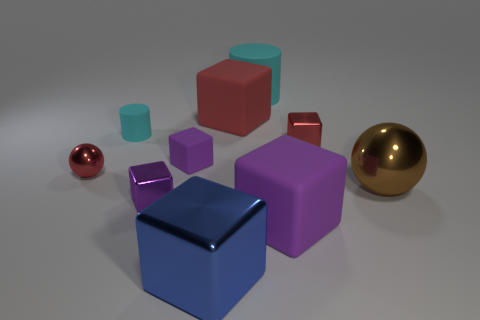There is a rubber object that is the same color as the small sphere; what is its size?
Keep it short and to the point. Large. Is the brown ball the same size as the purple shiny object?
Make the answer very short. No. The cylinder that is the same size as the brown metal thing is what color?
Provide a short and direct response. Cyan. Do the red rubber object and the shiny cube that is behind the brown shiny ball have the same size?
Provide a short and direct response. No. What number of tiny cylinders have the same color as the big cylinder?
Give a very brief answer. 1. What number of things are tiny red metal objects or large shiny things that are to the left of the small red metallic cube?
Make the answer very short. 3. There is a ball that is behind the large brown metal sphere; is it the same size as the matte cube that is in front of the big shiny ball?
Offer a very short reply. No. Is there another cyan object made of the same material as the large cyan thing?
Ensure brevity in your answer.  Yes. What is the shape of the brown object?
Give a very brief answer. Sphere. What is the shape of the red shiny object to the left of the big cube behind the tiny red ball?
Your answer should be compact. Sphere. 